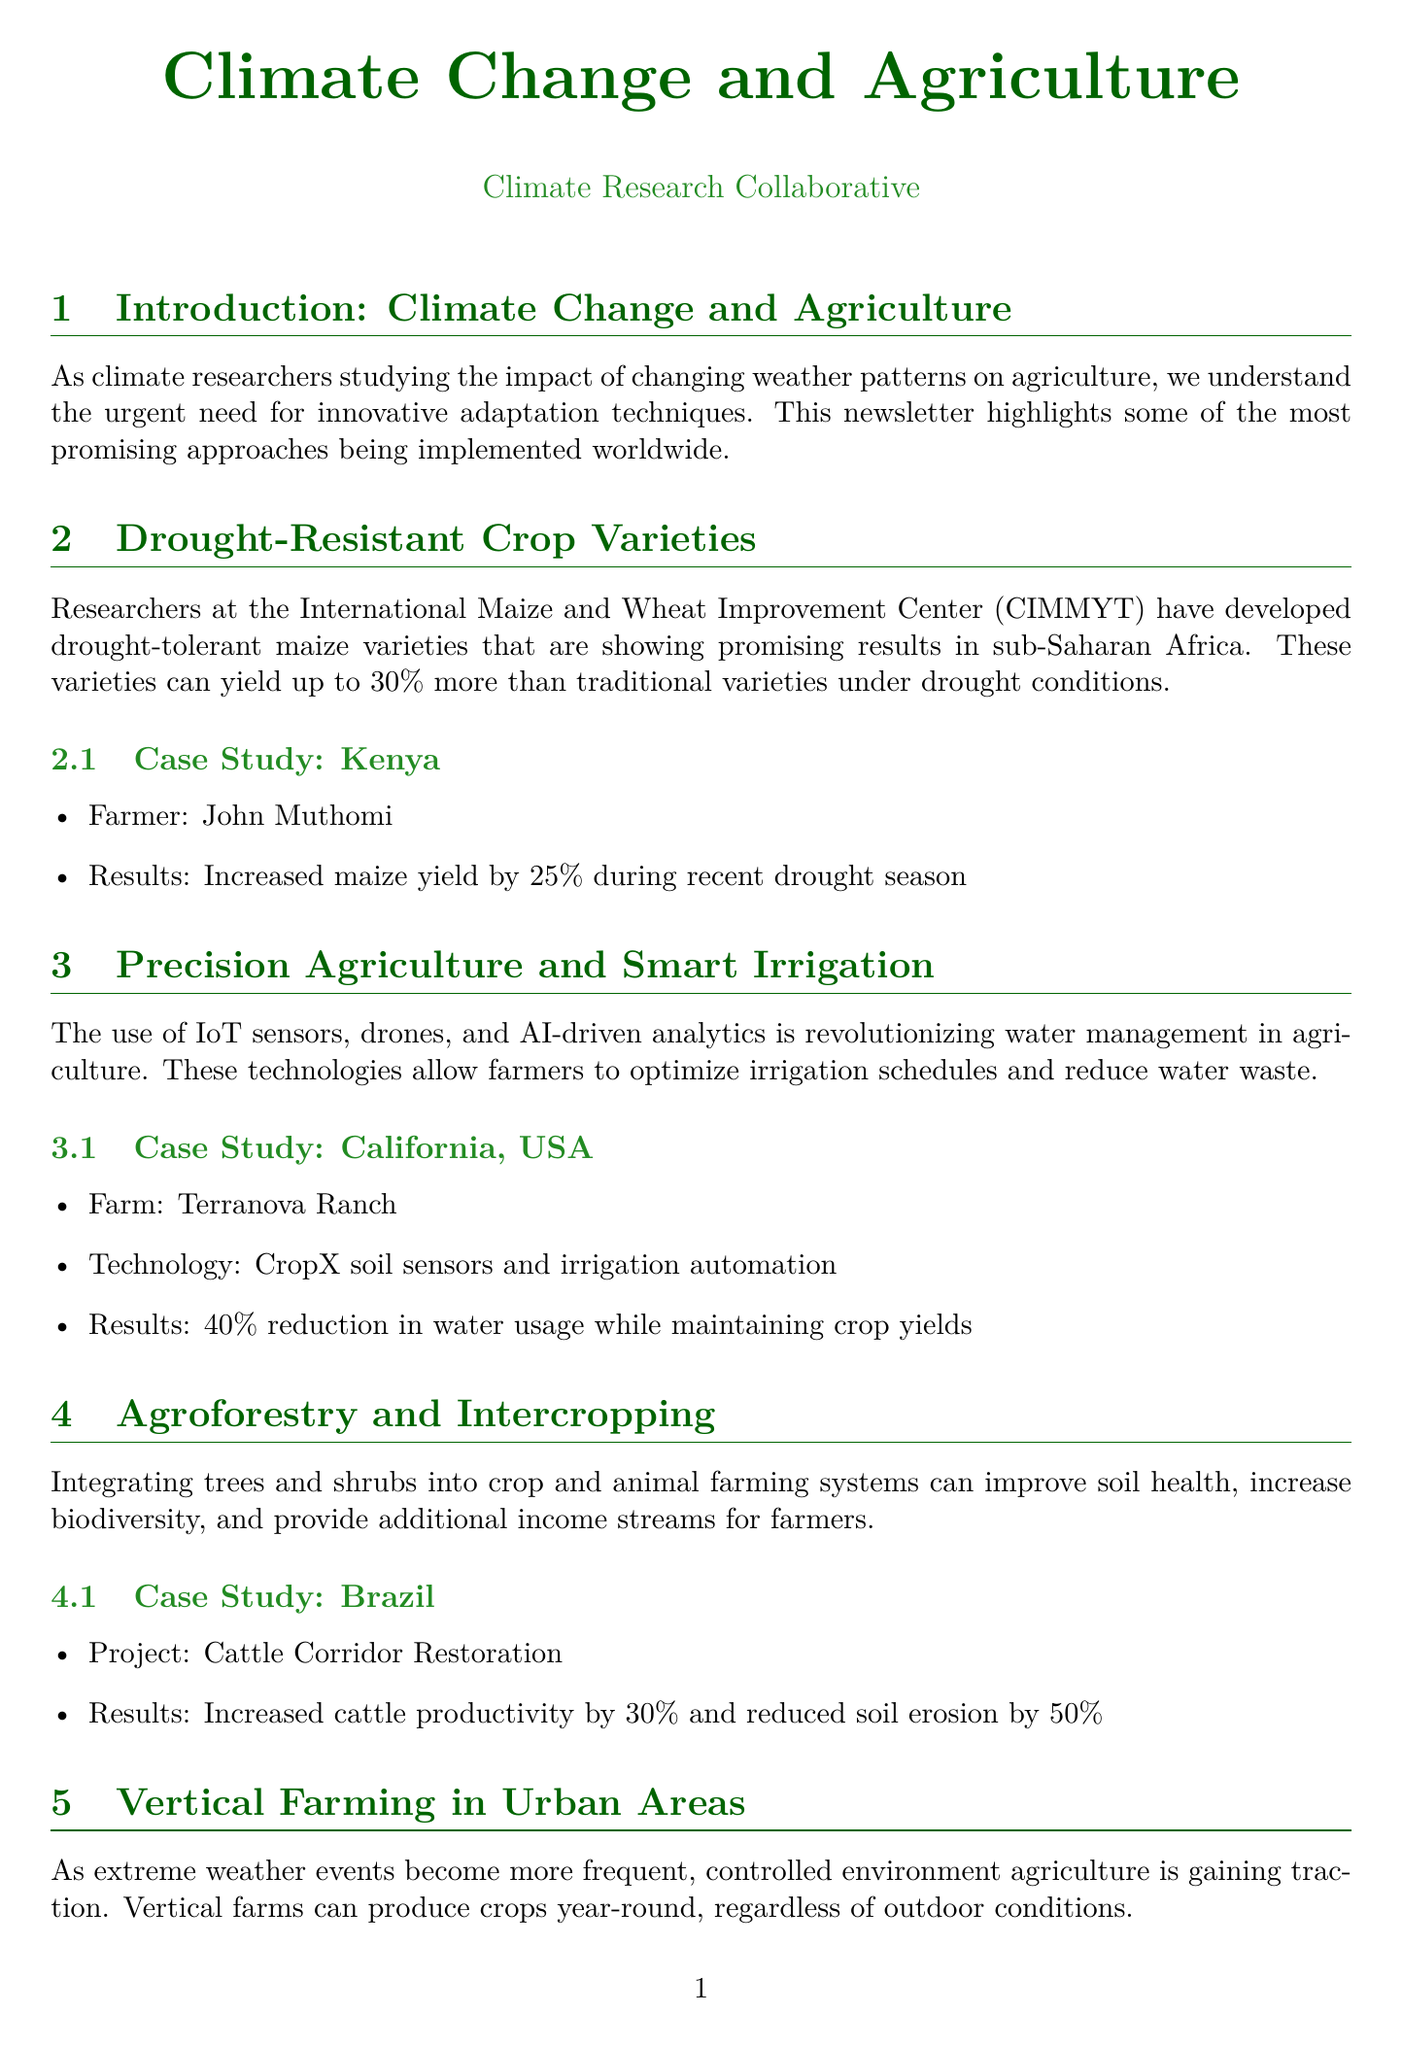What is the title of the newsletter? The title presents the central theme of the document, focusing on the link between climate change and agriculture.
Answer: Climate Change and Agriculture Who developed drought-tolerant maize varieties? This information identifies the organization contributing to agricultural innovation in drought conditions.
Answer: International Maize and Wheat Improvement Center (CIMMYT) What was the increase in maize yield reported in Kenya? This number reflects the effectiveness of the new crop variety showcased in the case study.
Answer: 25% What technology was used at Terranova Ranch? The technology mentioned is geared towards optimizing water management in agriculture.
Answer: CropX soil sensors and irrigation automation What percentage reduction in water usage was achieved in California? This percentage highlights the efficiency gained through the use of smart irrigation technologies.
Answer: 40% What were the results of the Cattle Corridor Restoration project in Brazil? This indicates the impact of agroforestry on cattle productivity and soil health.
Answer: Increased cattle productivity by 30% and reduced soil erosion by 50% How much water does Sky Greens use compared to traditional farming? This figure demonstrates the water efficiency achieved by vertical farming.
Answer: 95% less water What is the name of the offshore aquaculture facility in Norway? Identifying the facility provides insight into innovative aquaculture practices.
Answer: Ocean Farm 1 What is the aim of the newsletter's conclusion? The concluding section encapsulates the overarching goal of the featured case studies.
Answer: Global food security in the face of climate change 